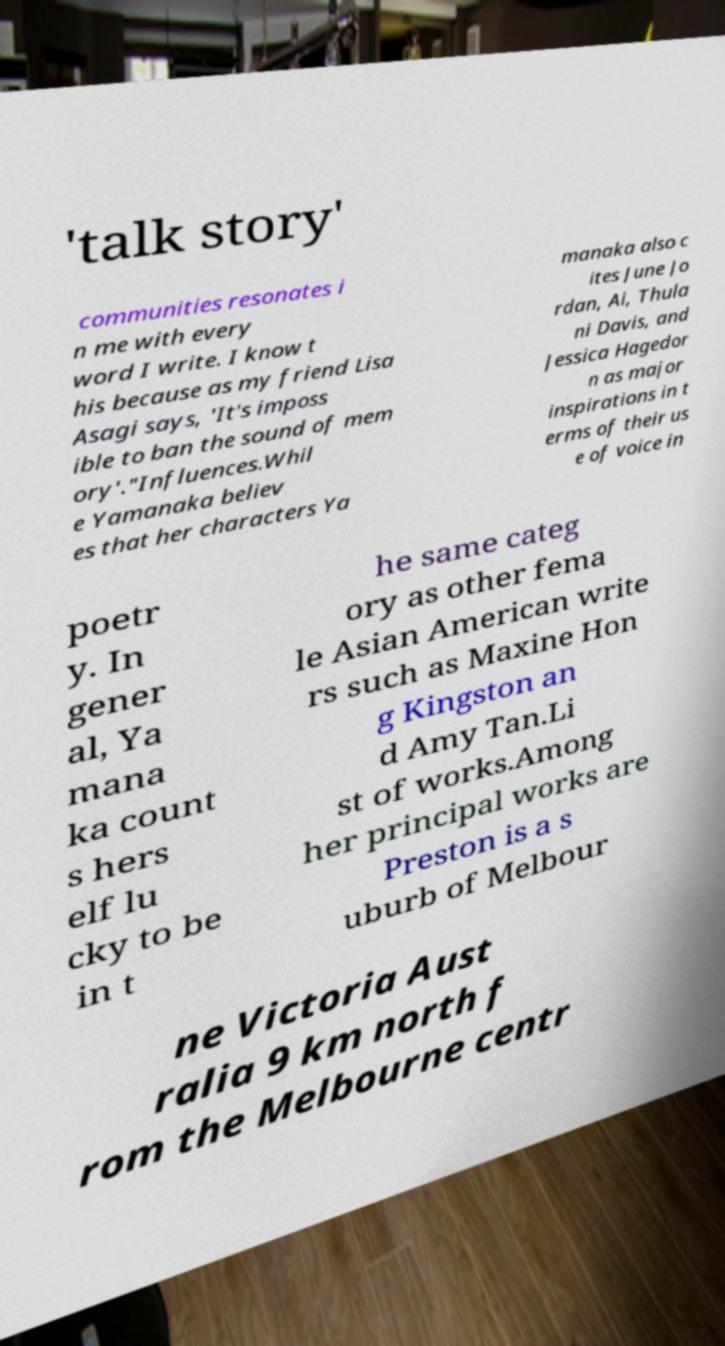For documentation purposes, I need the text within this image transcribed. Could you provide that? 'talk story' communities resonates i n me with every word I write. I know t his because as my friend Lisa Asagi says, 'It's imposs ible to ban the sound of mem ory'."Influences.Whil e Yamanaka believ es that her characters Ya manaka also c ites June Jo rdan, Ai, Thula ni Davis, and Jessica Hagedor n as major inspirations in t erms of their us e of voice in poetr y. In gener al, Ya mana ka count s hers elf lu cky to be in t he same categ ory as other fema le Asian American write rs such as Maxine Hon g Kingston an d Amy Tan.Li st of works.Among her principal works are Preston is a s uburb of Melbour ne Victoria Aust ralia 9 km north f rom the Melbourne centr 